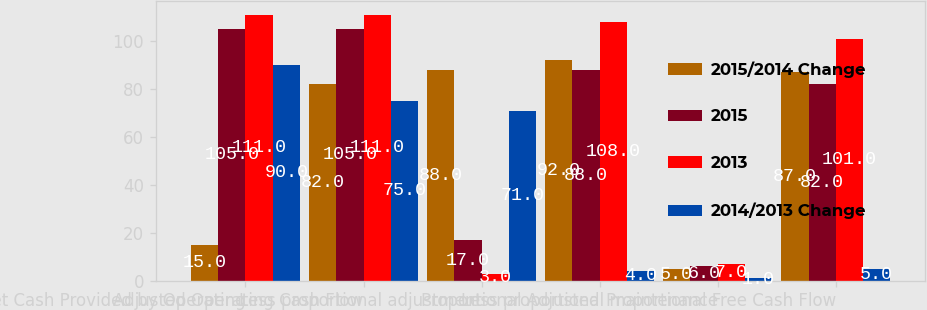Convert chart to OTSL. <chart><loc_0><loc_0><loc_500><loc_500><stacked_bar_chart><ecel><fcel>Net Cash Provided by Operating<fcel>Adjusted Operating Cash Flow<fcel>Less proportional adjustment<fcel>Proportional Adjusted<fcel>Less proportional maintenance<fcel>Proportional Free Cash Flow<nl><fcel>2015/2014 Change<fcel>15<fcel>82<fcel>88<fcel>92<fcel>5<fcel>87<nl><fcel>2015<fcel>105<fcel>105<fcel>17<fcel>88<fcel>6<fcel>82<nl><fcel>2013<fcel>111<fcel>111<fcel>3<fcel>108<fcel>7<fcel>101<nl><fcel>2014/2013 Change<fcel>90<fcel>75<fcel>71<fcel>4<fcel>1<fcel>5<nl></chart> 